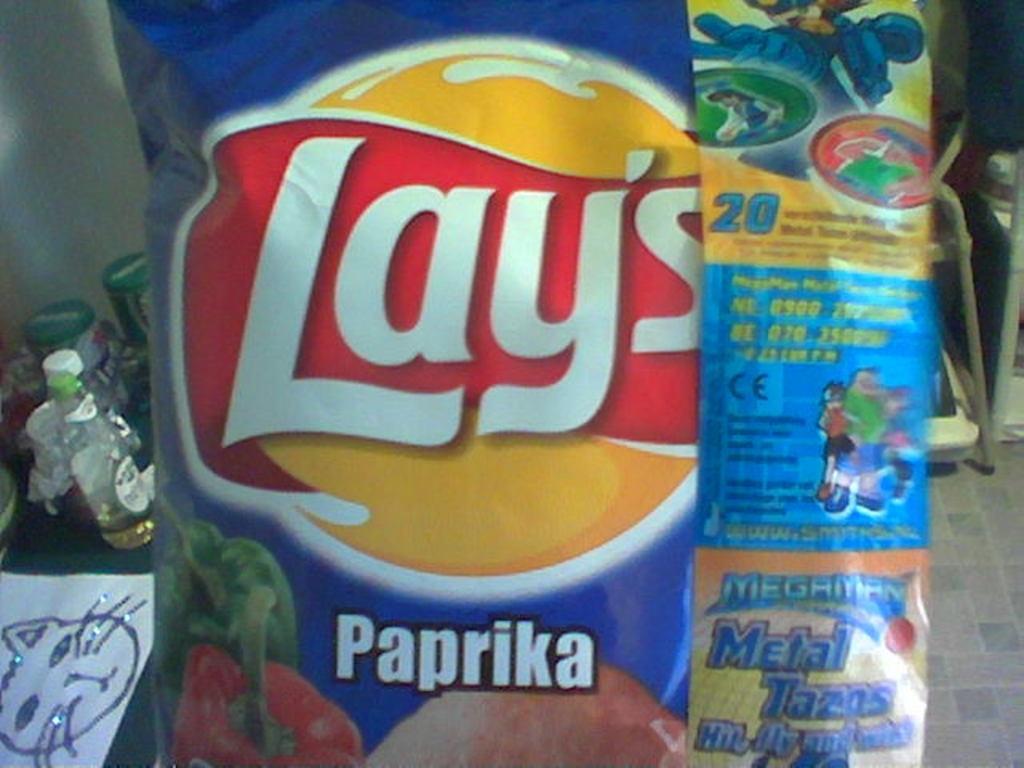Can you describe this image briefly? There is a cover with something written on that. In the back there are bottles, paper and many other things. 